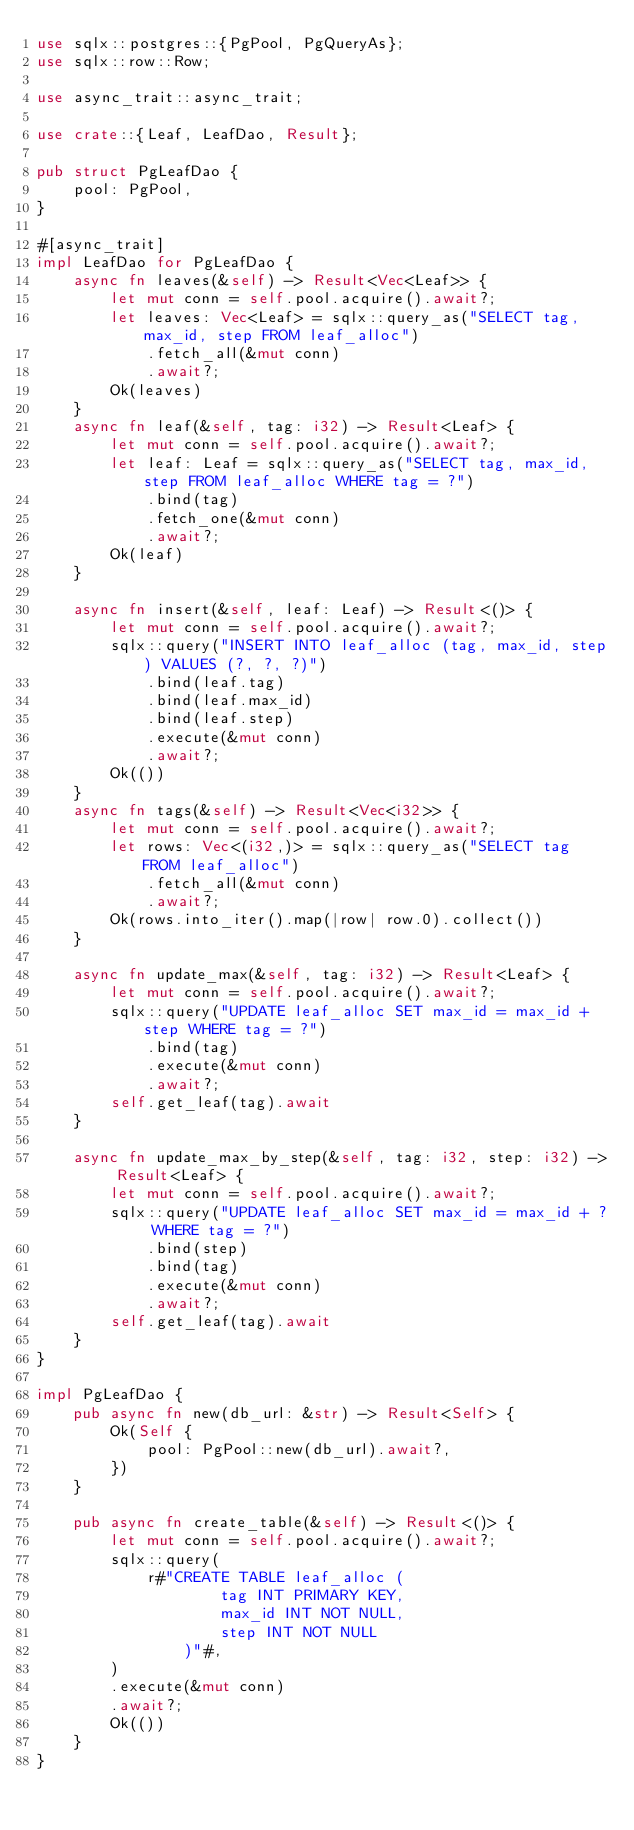Convert code to text. <code><loc_0><loc_0><loc_500><loc_500><_Rust_>use sqlx::postgres::{PgPool, PgQueryAs};
use sqlx::row::Row;

use async_trait::async_trait;

use crate::{Leaf, LeafDao, Result};

pub struct PgLeafDao {
    pool: PgPool,
}

#[async_trait]
impl LeafDao for PgLeafDao {
    async fn leaves(&self) -> Result<Vec<Leaf>> {
        let mut conn = self.pool.acquire().await?;
        let leaves: Vec<Leaf> = sqlx::query_as("SELECT tag, max_id, step FROM leaf_alloc")
            .fetch_all(&mut conn)
            .await?;
        Ok(leaves)
    }
    async fn leaf(&self, tag: i32) -> Result<Leaf> {
        let mut conn = self.pool.acquire().await?;
        let leaf: Leaf = sqlx::query_as("SELECT tag, max_id, step FROM leaf_alloc WHERE tag = ?")
            .bind(tag)
            .fetch_one(&mut conn)
            .await?;
        Ok(leaf)
    }

    async fn insert(&self, leaf: Leaf) -> Result<()> {
        let mut conn = self.pool.acquire().await?;
        sqlx::query("INSERT INTO leaf_alloc (tag, max_id, step) VALUES (?, ?, ?)")
            .bind(leaf.tag)
            .bind(leaf.max_id)
            .bind(leaf.step)
            .execute(&mut conn)
            .await?;
        Ok(())
    }
    async fn tags(&self) -> Result<Vec<i32>> {
        let mut conn = self.pool.acquire().await?;
        let rows: Vec<(i32,)> = sqlx::query_as("SELECT tag FROM leaf_alloc")
            .fetch_all(&mut conn)
            .await?;
        Ok(rows.into_iter().map(|row| row.0).collect())
    }

    async fn update_max(&self, tag: i32) -> Result<Leaf> {
        let mut conn = self.pool.acquire().await?;
        sqlx::query("UPDATE leaf_alloc SET max_id = max_id + step WHERE tag = ?")
            .bind(tag)
            .execute(&mut conn)
            .await?;
        self.get_leaf(tag).await
    }

    async fn update_max_by_step(&self, tag: i32, step: i32) -> Result<Leaf> {
        let mut conn = self.pool.acquire().await?;
        sqlx::query("UPDATE leaf_alloc SET max_id = max_id + ? WHERE tag = ?")
            .bind(step)
            .bind(tag)
            .execute(&mut conn)
            .await?;
        self.get_leaf(tag).await
    }
}

impl PgLeafDao {
    pub async fn new(db_url: &str) -> Result<Self> {
        Ok(Self {
            pool: PgPool::new(db_url).await?,
        })
    }

    pub async fn create_table(&self) -> Result<()> {
        let mut conn = self.pool.acquire().await?;
        sqlx::query(
            r#"CREATE TABLE leaf_alloc (
                    tag INT PRIMARY KEY,
                    max_id INT NOT NULL,
                    step INT NOT NULL
                )"#,
        )
        .execute(&mut conn)
        .await?;
        Ok(())
    }
}
</code> 